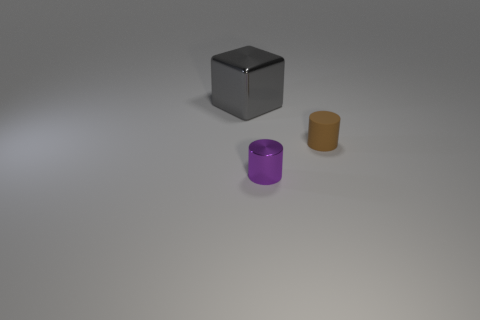Are there any other things that have the same color as the small matte object?
Your response must be concise. No. Do the brown matte object and the small shiny thing have the same shape?
Provide a succinct answer. Yes. There is a metal object behind the object that is right of the cylinder that is in front of the brown object; what size is it?
Offer a terse response. Large. How many other things are there of the same material as the purple thing?
Your response must be concise. 1. There is a metallic thing on the right side of the metallic block; what color is it?
Give a very brief answer. Purple. There is a small cylinder that is to the left of the small thing behind the metal object that is in front of the big object; what is it made of?
Offer a terse response. Metal. Are there any brown things of the same shape as the purple thing?
Ensure brevity in your answer.  Yes. What number of things are left of the tiny brown cylinder and behind the small metal thing?
Keep it short and to the point. 1. Is the number of tiny things in front of the big gray object less than the number of tiny matte cylinders?
Keep it short and to the point. No. Are there any yellow cylinders that have the same size as the gray metallic object?
Keep it short and to the point. No. 